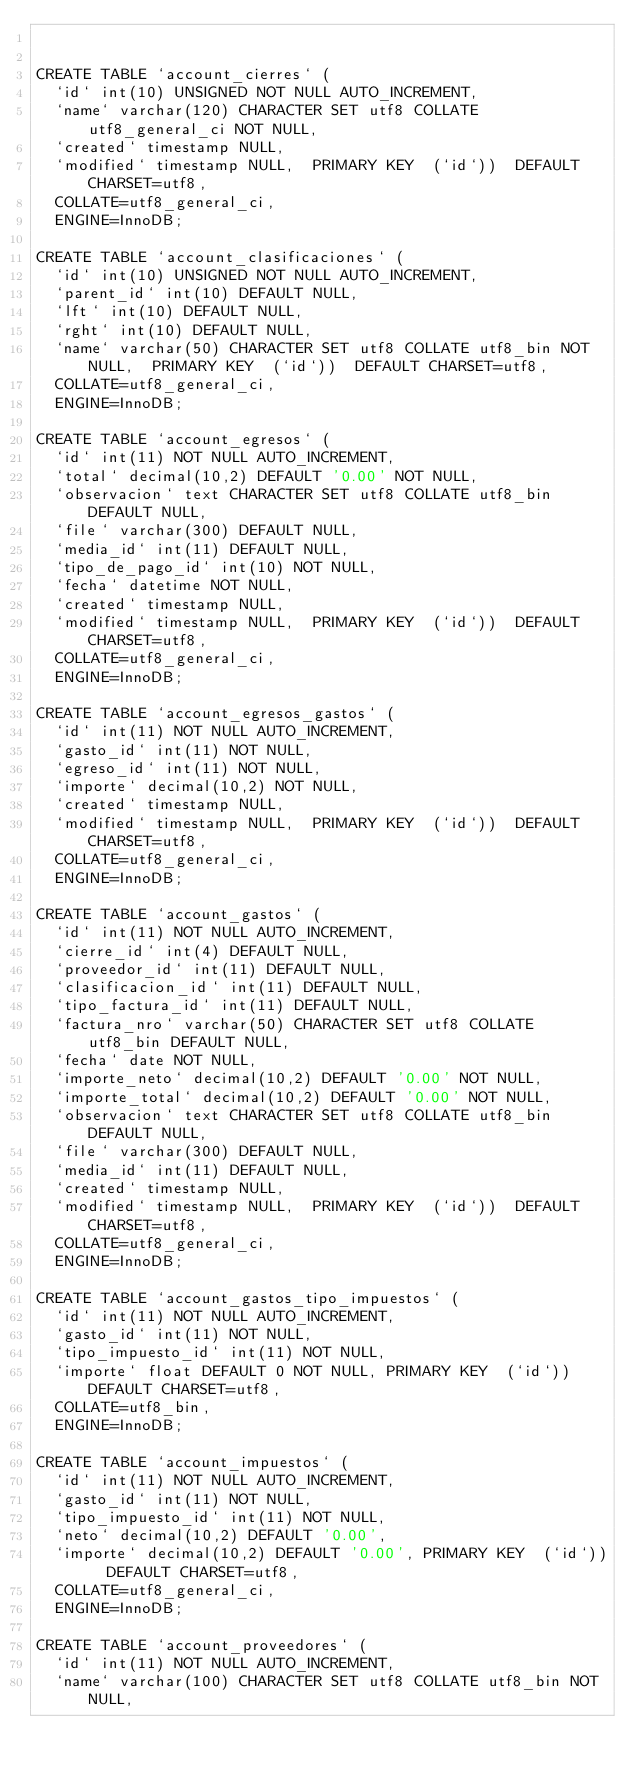Convert code to text. <code><loc_0><loc_0><loc_500><loc_500><_SQL_>

CREATE TABLE `account_cierres` (
  `id` int(10) UNSIGNED NOT NULL AUTO_INCREMENT,
  `name` varchar(120) CHARACTER SET utf8 COLLATE utf8_general_ci NOT NULL,
  `created` timestamp NULL,
  `modified` timestamp NULL,  PRIMARY KEY  (`id`))  DEFAULT CHARSET=utf8,
  COLLATE=utf8_general_ci,
  ENGINE=InnoDB;

CREATE TABLE `account_clasificaciones` (
  `id` int(10) UNSIGNED NOT NULL AUTO_INCREMENT,
  `parent_id` int(10) DEFAULT NULL,
  `lft` int(10) DEFAULT NULL,
  `rght` int(10) DEFAULT NULL,
  `name` varchar(50) CHARACTER SET utf8 COLLATE utf8_bin NOT NULL,  PRIMARY KEY  (`id`))  DEFAULT CHARSET=utf8,
  COLLATE=utf8_general_ci,
  ENGINE=InnoDB;

CREATE TABLE `account_egresos` (
  `id` int(11) NOT NULL AUTO_INCREMENT,
  `total` decimal(10,2) DEFAULT '0.00' NOT NULL,
  `observacion` text CHARACTER SET utf8 COLLATE utf8_bin DEFAULT NULL,
  `file` varchar(300) DEFAULT NULL,
  `media_id` int(11) DEFAULT NULL,
  `tipo_de_pago_id` int(10) NOT NULL,
  `fecha` datetime NOT NULL,
  `created` timestamp NULL,
  `modified` timestamp NULL,  PRIMARY KEY  (`id`))  DEFAULT CHARSET=utf8,
  COLLATE=utf8_general_ci,
  ENGINE=InnoDB;

CREATE TABLE `account_egresos_gastos` (
  `id` int(11) NOT NULL AUTO_INCREMENT,
  `gasto_id` int(11) NOT NULL,
  `egreso_id` int(11) NOT NULL,
  `importe` decimal(10,2) NOT NULL,
  `created` timestamp NULL,
  `modified` timestamp NULL,  PRIMARY KEY  (`id`))  DEFAULT CHARSET=utf8,
  COLLATE=utf8_general_ci,
  ENGINE=InnoDB;

CREATE TABLE `account_gastos` (
  `id` int(11) NOT NULL AUTO_INCREMENT,
  `cierre_id` int(4) DEFAULT NULL,
  `proveedor_id` int(11) DEFAULT NULL,
  `clasificacion_id` int(11) DEFAULT NULL,
  `tipo_factura_id` int(11) DEFAULT NULL,
  `factura_nro` varchar(50) CHARACTER SET utf8 COLLATE utf8_bin DEFAULT NULL,
  `fecha` date NOT NULL,
  `importe_neto` decimal(10,2) DEFAULT '0.00' NOT NULL,
  `importe_total` decimal(10,2) DEFAULT '0.00' NOT NULL,
  `observacion` text CHARACTER SET utf8 COLLATE utf8_bin DEFAULT NULL,
  `file` varchar(300) DEFAULT NULL,
  `media_id` int(11) DEFAULT NULL,
  `created` timestamp NULL,
  `modified` timestamp NULL,  PRIMARY KEY  (`id`))  DEFAULT CHARSET=utf8,
  COLLATE=utf8_general_ci,
  ENGINE=InnoDB;

CREATE TABLE `account_gastos_tipo_impuestos` (
  `id` int(11) NOT NULL AUTO_INCREMENT,
  `gasto_id` int(11) NOT NULL,
  `tipo_impuesto_id` int(11) NOT NULL,
  `importe` float DEFAULT 0 NOT NULL, PRIMARY KEY  (`id`))  DEFAULT CHARSET=utf8,
  COLLATE=utf8_bin,
  ENGINE=InnoDB;

CREATE TABLE `account_impuestos` (
  `id` int(11) NOT NULL AUTO_INCREMENT,
  `gasto_id` int(11) NOT NULL,
  `tipo_impuesto_id` int(11) NOT NULL,
  `neto` decimal(10,2) DEFAULT '0.00',
  `importe` decimal(10,2) DEFAULT '0.00', PRIMARY KEY  (`id`))  DEFAULT CHARSET=utf8,
  COLLATE=utf8_general_ci,
  ENGINE=InnoDB;

CREATE TABLE `account_proveedores` (
  `id` int(11) NOT NULL AUTO_INCREMENT,
  `name` varchar(100) CHARACTER SET utf8 COLLATE utf8_bin NOT NULL,</code> 